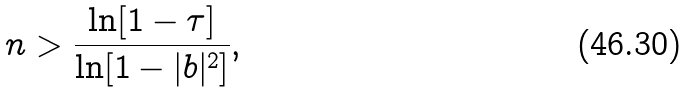<formula> <loc_0><loc_0><loc_500><loc_500>n > \frac { \ln [ 1 - \tau ] } { \ln [ 1 - | b | ^ { 2 } ] } ,</formula> 